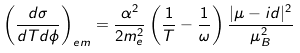Convert formula to latex. <formula><loc_0><loc_0><loc_500><loc_500>\left ( \frac { d \sigma } { d T d \phi } \right ) _ { e m } = \frac { \alpha ^ { 2 } } { 2 m _ { e } ^ { 2 } } \left ( \frac { 1 } { T } - \frac { 1 } { \omega } \right ) \frac { | \mu - i d | ^ { 2 } } { \mu _ { B } ^ { 2 } }</formula> 